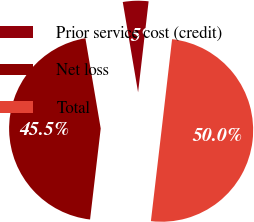Convert chart to OTSL. <chart><loc_0><loc_0><loc_500><loc_500><pie_chart><fcel>Prior service cost (credit)<fcel>Net loss<fcel>Total<nl><fcel>4.51%<fcel>45.47%<fcel>50.02%<nl></chart> 